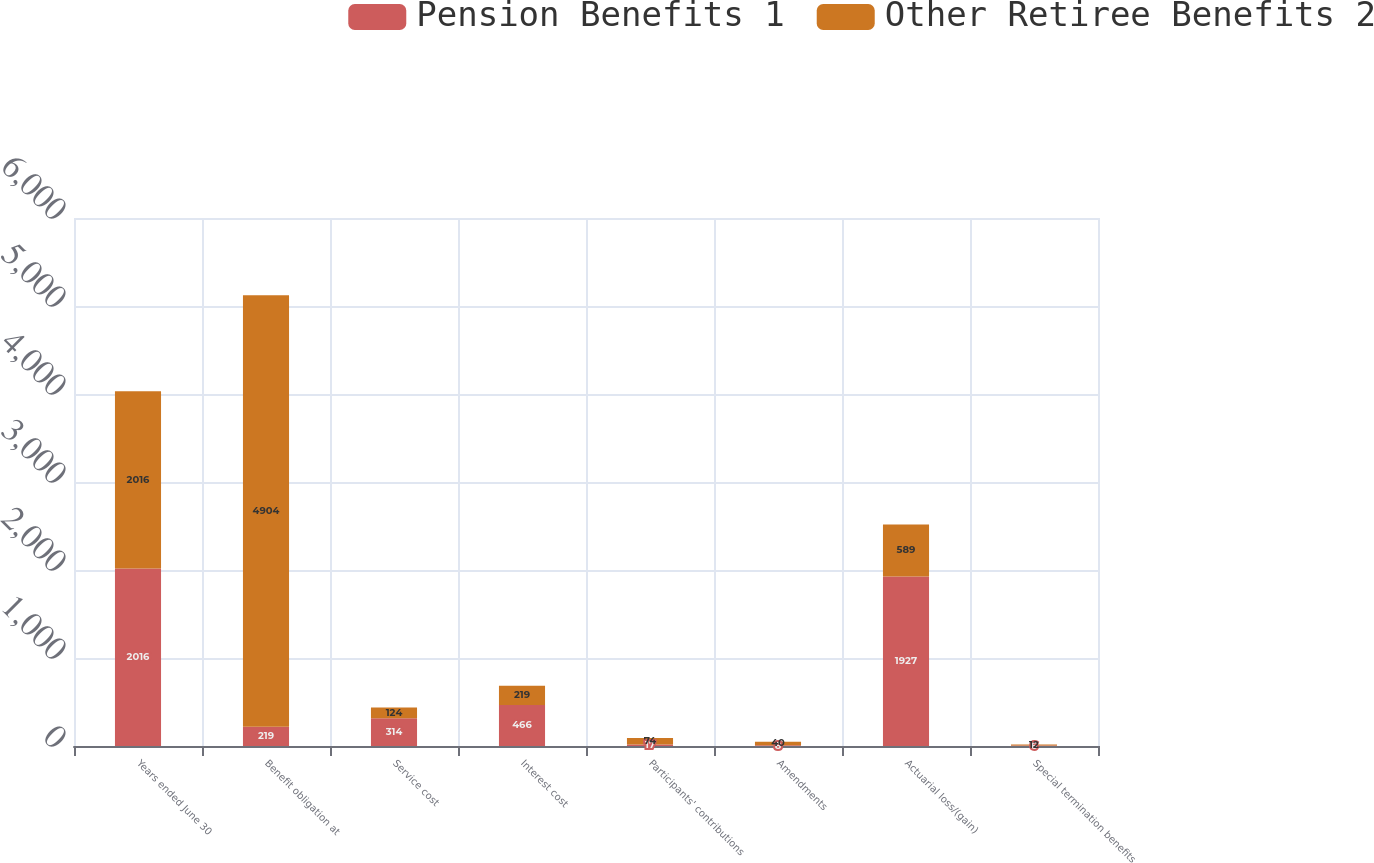Convert chart to OTSL. <chart><loc_0><loc_0><loc_500><loc_500><stacked_bar_chart><ecel><fcel>Years ended June 30<fcel>Benefit obligation at<fcel>Service cost<fcel>Interest cost<fcel>Participants' contributions<fcel>Amendments<fcel>Actuarial loss/(gain)<fcel>Special termination benefits<nl><fcel>Pension Benefits 1<fcel>2016<fcel>219<fcel>314<fcel>466<fcel>17<fcel>8<fcel>1927<fcel>6<nl><fcel>Other Retiree Benefits 2<fcel>2016<fcel>4904<fcel>124<fcel>219<fcel>74<fcel>40<fcel>589<fcel>12<nl></chart> 